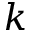<formula> <loc_0><loc_0><loc_500><loc_500>k</formula> 